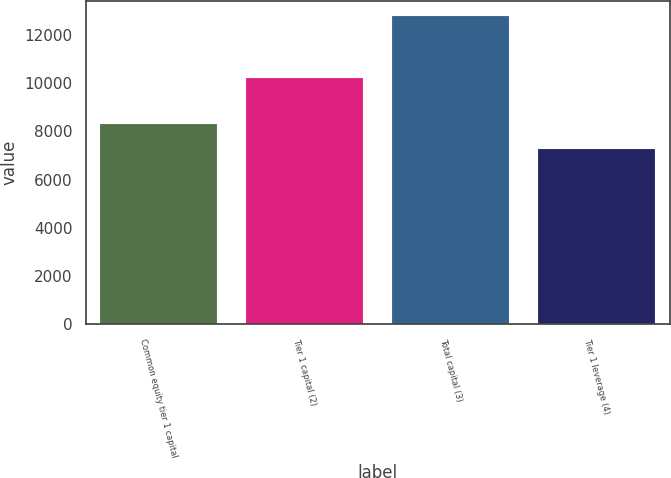Convert chart to OTSL. <chart><loc_0><loc_0><loc_500><loc_500><bar_chart><fcel>Common equity tier 1 capital<fcel>Tier 1 capital (2)<fcel>Total capital (3)<fcel>Tier 1 leverage (4)<nl><fcel>8300<fcel>10215<fcel>12769<fcel>7280<nl></chart> 